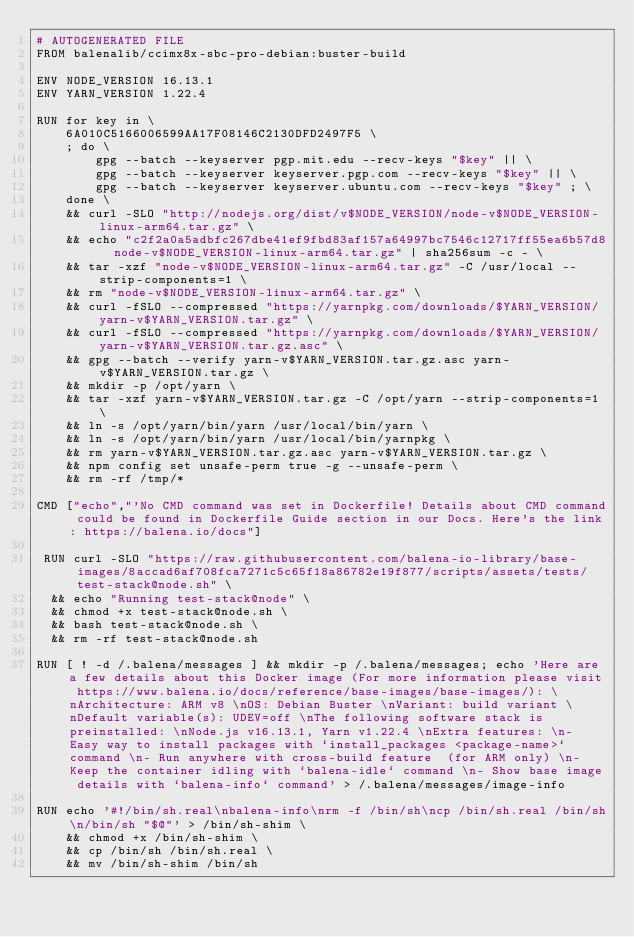<code> <loc_0><loc_0><loc_500><loc_500><_Dockerfile_># AUTOGENERATED FILE
FROM balenalib/ccimx8x-sbc-pro-debian:buster-build

ENV NODE_VERSION 16.13.1
ENV YARN_VERSION 1.22.4

RUN for key in \
	6A010C5166006599AA17F08146C2130DFD2497F5 \
	; do \
		gpg --batch --keyserver pgp.mit.edu --recv-keys "$key" || \
		gpg --batch --keyserver keyserver.pgp.com --recv-keys "$key" || \
		gpg --batch --keyserver keyserver.ubuntu.com --recv-keys "$key" ; \
	done \
	&& curl -SLO "http://nodejs.org/dist/v$NODE_VERSION/node-v$NODE_VERSION-linux-arm64.tar.gz" \
	&& echo "c2f2a0a5adbfc267dbe41ef9fbd83af157a64997bc7546c12717ff55ea6b57d8  node-v$NODE_VERSION-linux-arm64.tar.gz" | sha256sum -c - \
	&& tar -xzf "node-v$NODE_VERSION-linux-arm64.tar.gz" -C /usr/local --strip-components=1 \
	&& rm "node-v$NODE_VERSION-linux-arm64.tar.gz" \
	&& curl -fSLO --compressed "https://yarnpkg.com/downloads/$YARN_VERSION/yarn-v$YARN_VERSION.tar.gz" \
	&& curl -fSLO --compressed "https://yarnpkg.com/downloads/$YARN_VERSION/yarn-v$YARN_VERSION.tar.gz.asc" \
	&& gpg --batch --verify yarn-v$YARN_VERSION.tar.gz.asc yarn-v$YARN_VERSION.tar.gz \
	&& mkdir -p /opt/yarn \
	&& tar -xzf yarn-v$YARN_VERSION.tar.gz -C /opt/yarn --strip-components=1 \
	&& ln -s /opt/yarn/bin/yarn /usr/local/bin/yarn \
	&& ln -s /opt/yarn/bin/yarn /usr/local/bin/yarnpkg \
	&& rm yarn-v$YARN_VERSION.tar.gz.asc yarn-v$YARN_VERSION.tar.gz \
	&& npm config set unsafe-perm true -g --unsafe-perm \
	&& rm -rf /tmp/*

CMD ["echo","'No CMD command was set in Dockerfile! Details about CMD command could be found in Dockerfile Guide section in our Docs. Here's the link: https://balena.io/docs"]

 RUN curl -SLO "https://raw.githubusercontent.com/balena-io-library/base-images/8accad6af708fca7271c5c65f18a86782e19f877/scripts/assets/tests/test-stack@node.sh" \
  && echo "Running test-stack@node" \
  && chmod +x test-stack@node.sh \
  && bash test-stack@node.sh \
  && rm -rf test-stack@node.sh 

RUN [ ! -d /.balena/messages ] && mkdir -p /.balena/messages; echo 'Here are a few details about this Docker image (For more information please visit https://www.balena.io/docs/reference/base-images/base-images/): \nArchitecture: ARM v8 \nOS: Debian Buster \nVariant: build variant \nDefault variable(s): UDEV=off \nThe following software stack is preinstalled: \nNode.js v16.13.1, Yarn v1.22.4 \nExtra features: \n- Easy way to install packages with `install_packages <package-name>` command \n- Run anywhere with cross-build feature  (for ARM only) \n- Keep the container idling with `balena-idle` command \n- Show base image details with `balena-info` command' > /.balena/messages/image-info

RUN echo '#!/bin/sh.real\nbalena-info\nrm -f /bin/sh\ncp /bin/sh.real /bin/sh\n/bin/sh "$@"' > /bin/sh-shim \
	&& chmod +x /bin/sh-shim \
	&& cp /bin/sh /bin/sh.real \
	&& mv /bin/sh-shim /bin/sh</code> 